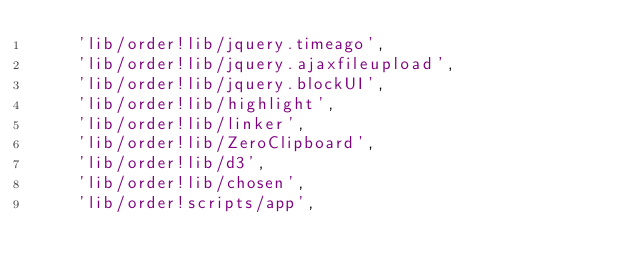<code> <loc_0><loc_0><loc_500><loc_500><_JavaScript_>    'lib/order!lib/jquery.timeago',
    'lib/order!lib/jquery.ajaxfileupload',
    'lib/order!lib/jquery.blockUI',
    'lib/order!lib/highlight',
    'lib/order!lib/linker',
    'lib/order!lib/ZeroClipboard',
    'lib/order!lib/d3',
    'lib/order!lib/chosen',
    'lib/order!scripts/app',
</code> 